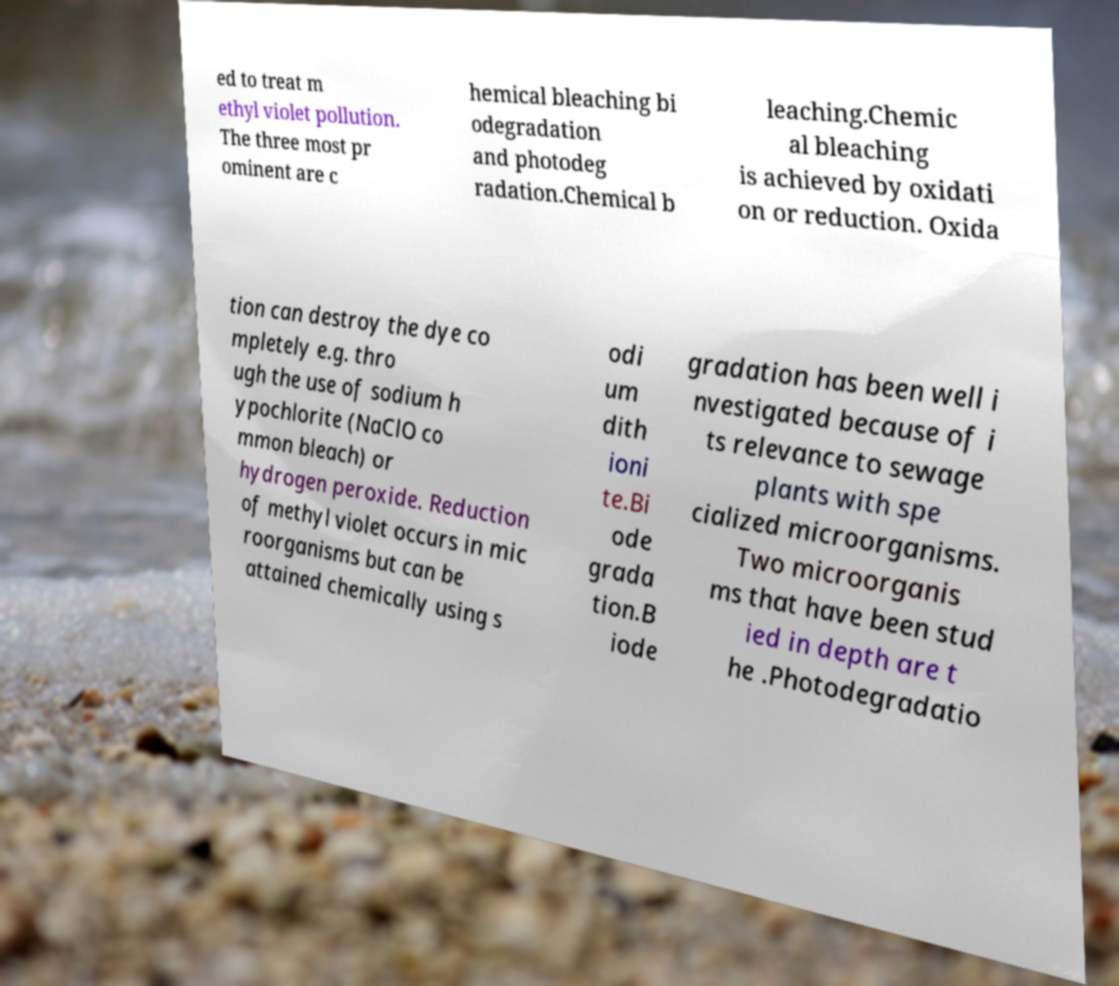I need the written content from this picture converted into text. Can you do that? ed to treat m ethyl violet pollution. The three most pr ominent are c hemical bleaching bi odegradation and photodeg radation.Chemical b leaching.Chemic al bleaching is achieved by oxidati on or reduction. Oxida tion can destroy the dye co mpletely e.g. thro ugh the use of sodium h ypochlorite (NaClO co mmon bleach) or hydrogen peroxide. Reduction of methyl violet occurs in mic roorganisms but can be attained chemically using s odi um dith ioni te.Bi ode grada tion.B iode gradation has been well i nvestigated because of i ts relevance to sewage plants with spe cialized microorganisms. Two microorganis ms that have been stud ied in depth are t he .Photodegradatio 